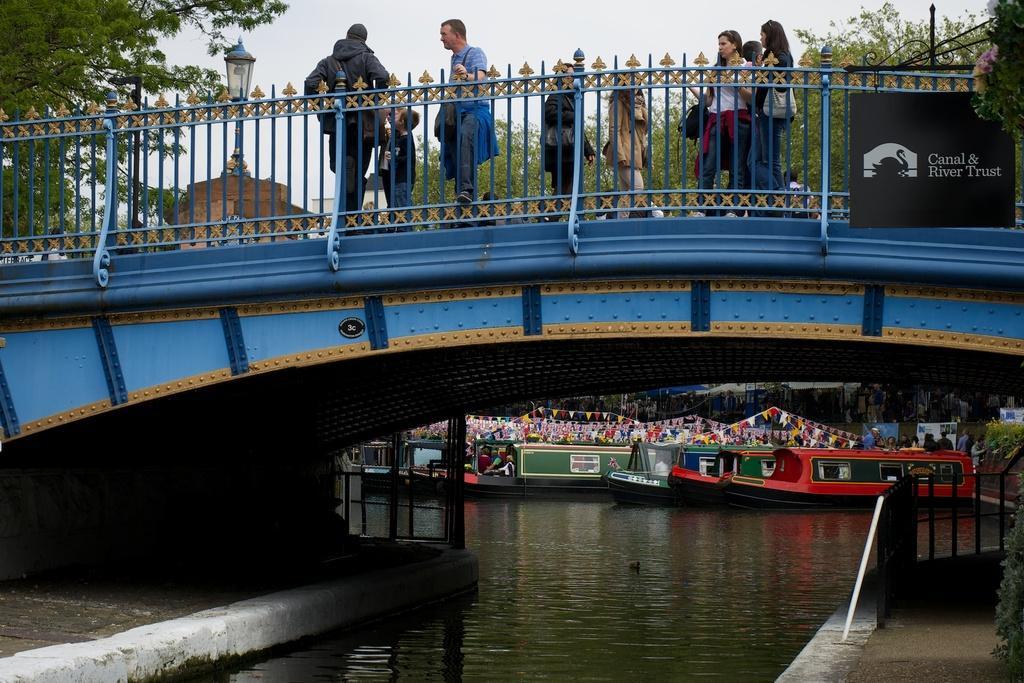Could you give a brief overview of what you see in this image? In this image we can see a bridge. On the bridge we can see few persons, a board with text and a light. Behind the bridge we can see boats, water, flags and trees. There are few persons in the boat. In the top left, we can see a tree. At the top we can see the sky. 